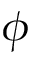Convert formula to latex. <formula><loc_0><loc_0><loc_500><loc_500>\phi</formula> 